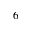<formula> <loc_0><loc_0><loc_500><loc_500>6</formula> 